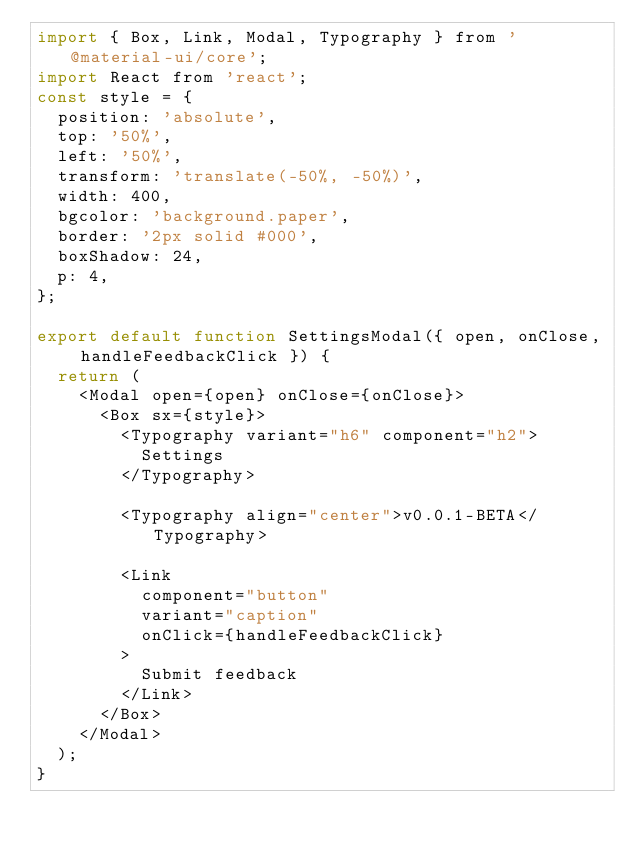Convert code to text. <code><loc_0><loc_0><loc_500><loc_500><_JavaScript_>import { Box, Link, Modal, Typography } from '@material-ui/core';
import React from 'react';
const style = {
  position: 'absolute',
  top: '50%',
  left: '50%',
  transform: 'translate(-50%, -50%)',
  width: 400,
  bgcolor: 'background.paper',
  border: '2px solid #000',
  boxShadow: 24,
  p: 4,
};

export default function SettingsModal({ open, onClose, handleFeedbackClick }) {
  return (
    <Modal open={open} onClose={onClose}>
      <Box sx={style}>
        <Typography variant="h6" component="h2">
          Settings
        </Typography>

        <Typography align="center">v0.0.1-BETA</Typography>

        <Link
          component="button"
          variant="caption"
          onClick={handleFeedbackClick}
        >
          Submit feedback
        </Link>
      </Box>
    </Modal>
  );
}
</code> 